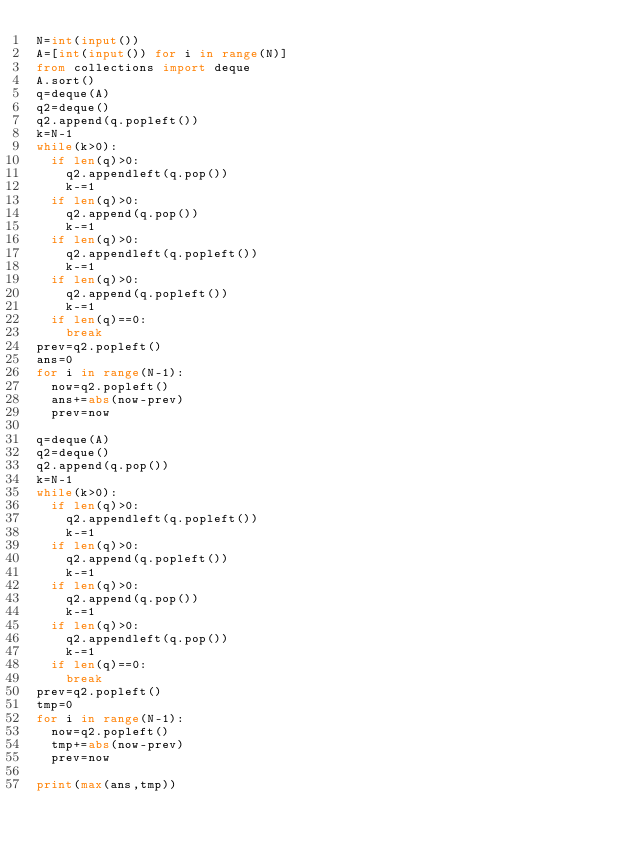Convert code to text. <code><loc_0><loc_0><loc_500><loc_500><_Python_>N=int(input())
A=[int(input()) for i in range(N)]
from collections import deque
A.sort()
q=deque(A)
q2=deque()
q2.append(q.popleft())
k=N-1
while(k>0):
  if len(q)>0:
    q2.appendleft(q.pop())
    k-=1
  if len(q)>0:
    q2.append(q.pop())
    k-=1
  if len(q)>0:
    q2.appendleft(q.popleft())
    k-=1
  if len(q)>0:
    q2.append(q.popleft())
    k-=1
  if len(q)==0:
    break
prev=q2.popleft()
ans=0
for i in range(N-1):
  now=q2.popleft()
  ans+=abs(now-prev)
  prev=now

q=deque(A)
q2=deque()
q2.append(q.pop())
k=N-1
while(k>0):
  if len(q)>0:
    q2.appendleft(q.popleft())
    k-=1
  if len(q)>0:
    q2.append(q.popleft())
    k-=1
  if len(q)>0:
    q2.append(q.pop())
    k-=1
  if len(q)>0:
    q2.appendleft(q.pop())
    k-=1
  if len(q)==0:
    break
prev=q2.popleft()
tmp=0
for i in range(N-1):
  now=q2.popleft()
  tmp+=abs(now-prev)
  prev=now  
  
print(max(ans,tmp))  </code> 